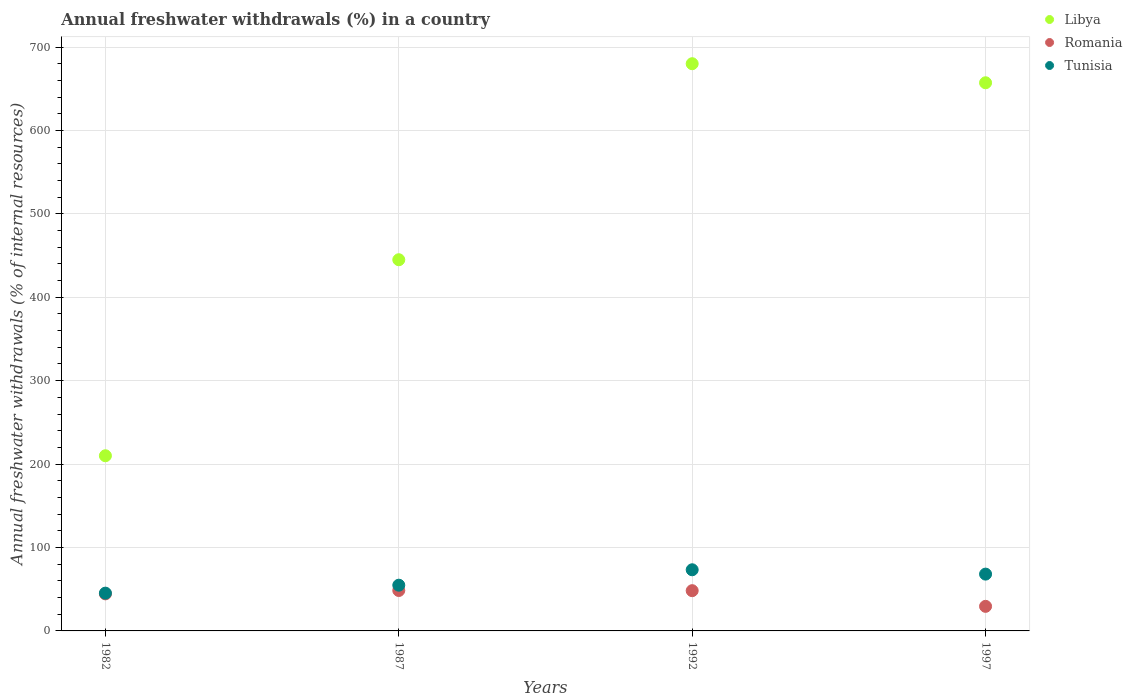Is the number of dotlines equal to the number of legend labels?
Ensure brevity in your answer.  Yes. What is the percentage of annual freshwater withdrawals in Romania in 1982?
Keep it short and to the point. 44.44. Across all years, what is the maximum percentage of annual freshwater withdrawals in Libya?
Make the answer very short. 680. Across all years, what is the minimum percentage of annual freshwater withdrawals in Tunisia?
Offer a very short reply. 45.29. What is the total percentage of annual freshwater withdrawals in Romania in the graph?
Your answer should be very brief. 170.61. What is the difference between the percentage of annual freshwater withdrawals in Tunisia in 1982 and that in 1987?
Ensure brevity in your answer.  -9.54. What is the difference between the percentage of annual freshwater withdrawals in Romania in 1992 and the percentage of annual freshwater withdrawals in Tunisia in 1982?
Make the answer very short. 2.96. What is the average percentage of annual freshwater withdrawals in Libya per year?
Make the answer very short. 498.04. In the year 1997, what is the difference between the percentage of annual freshwater withdrawals in Romania and percentage of annual freshwater withdrawals in Tunisia?
Make the answer very short. -38.65. What is the ratio of the percentage of annual freshwater withdrawals in Libya in 1992 to that in 1997?
Provide a succinct answer. 1.03. Is the percentage of annual freshwater withdrawals in Tunisia in 1987 less than that in 1997?
Your response must be concise. Yes. What is the difference between the highest and the second highest percentage of annual freshwater withdrawals in Romania?
Your answer should be very brief. 0.21. What is the difference between the highest and the lowest percentage of annual freshwater withdrawals in Tunisia?
Your answer should be very brief. 28.01. Is the sum of the percentage of annual freshwater withdrawals in Romania in 1987 and 1992 greater than the maximum percentage of annual freshwater withdrawals in Libya across all years?
Your answer should be compact. No. Is it the case that in every year, the sum of the percentage of annual freshwater withdrawals in Libya and percentage of annual freshwater withdrawals in Tunisia  is greater than the percentage of annual freshwater withdrawals in Romania?
Keep it short and to the point. Yes. Does the percentage of annual freshwater withdrawals in Libya monotonically increase over the years?
Provide a succinct answer. No. Is the percentage of annual freshwater withdrawals in Romania strictly greater than the percentage of annual freshwater withdrawals in Tunisia over the years?
Your response must be concise. No. Is the percentage of annual freshwater withdrawals in Libya strictly less than the percentage of annual freshwater withdrawals in Tunisia over the years?
Ensure brevity in your answer.  No. How many dotlines are there?
Your answer should be compact. 3. Are the values on the major ticks of Y-axis written in scientific E-notation?
Offer a very short reply. No. How many legend labels are there?
Your response must be concise. 3. What is the title of the graph?
Make the answer very short. Annual freshwater withdrawals (%) in a country. Does "China" appear as one of the legend labels in the graph?
Your answer should be compact. No. What is the label or title of the X-axis?
Offer a very short reply. Years. What is the label or title of the Y-axis?
Offer a very short reply. Annual freshwater withdrawals (% of internal resources). What is the Annual freshwater withdrawals (% of internal resources) in Libya in 1982?
Your response must be concise. 210. What is the Annual freshwater withdrawals (% of internal resources) in Romania in 1982?
Provide a succinct answer. 44.44. What is the Annual freshwater withdrawals (% of internal resources) in Tunisia in 1982?
Your answer should be compact. 45.29. What is the Annual freshwater withdrawals (% of internal resources) in Libya in 1987?
Provide a short and direct response. 445. What is the Annual freshwater withdrawals (% of internal resources) in Romania in 1987?
Your answer should be very brief. 48.46. What is the Annual freshwater withdrawals (% of internal resources) of Tunisia in 1987?
Provide a short and direct response. 54.83. What is the Annual freshwater withdrawals (% of internal resources) in Libya in 1992?
Give a very brief answer. 680. What is the Annual freshwater withdrawals (% of internal resources) of Romania in 1992?
Make the answer very short. 48.25. What is the Annual freshwater withdrawals (% of internal resources) in Tunisia in 1992?
Your answer should be compact. 73.3. What is the Annual freshwater withdrawals (% of internal resources) in Libya in 1997?
Provide a short and direct response. 657.14. What is the Annual freshwater withdrawals (% of internal resources) in Romania in 1997?
Your answer should be very brief. 29.46. What is the Annual freshwater withdrawals (% of internal resources) in Tunisia in 1997?
Your answer should be very brief. 68.1. Across all years, what is the maximum Annual freshwater withdrawals (% of internal resources) in Libya?
Offer a very short reply. 680. Across all years, what is the maximum Annual freshwater withdrawals (% of internal resources) of Romania?
Offer a terse response. 48.46. Across all years, what is the maximum Annual freshwater withdrawals (% of internal resources) of Tunisia?
Provide a succinct answer. 73.3. Across all years, what is the minimum Annual freshwater withdrawals (% of internal resources) of Libya?
Provide a short and direct response. 210. Across all years, what is the minimum Annual freshwater withdrawals (% of internal resources) in Romania?
Keep it short and to the point. 29.46. Across all years, what is the minimum Annual freshwater withdrawals (% of internal resources) in Tunisia?
Give a very brief answer. 45.29. What is the total Annual freshwater withdrawals (% of internal resources) in Libya in the graph?
Offer a terse response. 1992.14. What is the total Annual freshwater withdrawals (% of internal resources) in Romania in the graph?
Offer a terse response. 170.61. What is the total Annual freshwater withdrawals (% of internal resources) of Tunisia in the graph?
Offer a very short reply. 241.53. What is the difference between the Annual freshwater withdrawals (% of internal resources) of Libya in 1982 and that in 1987?
Keep it short and to the point. -235. What is the difference between the Annual freshwater withdrawals (% of internal resources) of Romania in 1982 and that in 1987?
Provide a short and direct response. -4.02. What is the difference between the Annual freshwater withdrawals (% of internal resources) in Tunisia in 1982 and that in 1987?
Your answer should be compact. -9.54. What is the difference between the Annual freshwater withdrawals (% of internal resources) in Libya in 1982 and that in 1992?
Keep it short and to the point. -470. What is the difference between the Annual freshwater withdrawals (% of internal resources) in Romania in 1982 and that in 1992?
Your response must be concise. -3.81. What is the difference between the Annual freshwater withdrawals (% of internal resources) of Tunisia in 1982 and that in 1992?
Give a very brief answer. -28.01. What is the difference between the Annual freshwater withdrawals (% of internal resources) in Libya in 1982 and that in 1997?
Make the answer very short. -447.14. What is the difference between the Annual freshwater withdrawals (% of internal resources) of Romania in 1982 and that in 1997?
Keep it short and to the point. 14.99. What is the difference between the Annual freshwater withdrawals (% of internal resources) of Tunisia in 1982 and that in 1997?
Make the answer very short. -22.81. What is the difference between the Annual freshwater withdrawals (% of internal resources) of Libya in 1987 and that in 1992?
Your answer should be compact. -235. What is the difference between the Annual freshwater withdrawals (% of internal resources) of Romania in 1987 and that in 1992?
Keep it short and to the point. 0.21. What is the difference between the Annual freshwater withdrawals (% of internal resources) of Tunisia in 1987 and that in 1992?
Your answer should be compact. -18.47. What is the difference between the Annual freshwater withdrawals (% of internal resources) of Libya in 1987 and that in 1997?
Make the answer very short. -212.14. What is the difference between the Annual freshwater withdrawals (% of internal resources) in Romania in 1987 and that in 1997?
Your answer should be very brief. 19.01. What is the difference between the Annual freshwater withdrawals (% of internal resources) in Tunisia in 1987 and that in 1997?
Your answer should be very brief. -13.28. What is the difference between the Annual freshwater withdrawals (% of internal resources) of Libya in 1992 and that in 1997?
Your response must be concise. 22.86. What is the difference between the Annual freshwater withdrawals (% of internal resources) of Romania in 1992 and that in 1997?
Offer a terse response. 18.79. What is the difference between the Annual freshwater withdrawals (% of internal resources) in Tunisia in 1992 and that in 1997?
Offer a terse response. 5.2. What is the difference between the Annual freshwater withdrawals (% of internal resources) of Libya in 1982 and the Annual freshwater withdrawals (% of internal resources) of Romania in 1987?
Offer a terse response. 161.54. What is the difference between the Annual freshwater withdrawals (% of internal resources) of Libya in 1982 and the Annual freshwater withdrawals (% of internal resources) of Tunisia in 1987?
Your response must be concise. 155.17. What is the difference between the Annual freshwater withdrawals (% of internal resources) in Romania in 1982 and the Annual freshwater withdrawals (% of internal resources) in Tunisia in 1987?
Provide a succinct answer. -10.38. What is the difference between the Annual freshwater withdrawals (% of internal resources) in Libya in 1982 and the Annual freshwater withdrawals (% of internal resources) in Romania in 1992?
Provide a short and direct response. 161.75. What is the difference between the Annual freshwater withdrawals (% of internal resources) in Libya in 1982 and the Annual freshwater withdrawals (% of internal resources) in Tunisia in 1992?
Keep it short and to the point. 136.7. What is the difference between the Annual freshwater withdrawals (% of internal resources) of Romania in 1982 and the Annual freshwater withdrawals (% of internal resources) of Tunisia in 1992?
Ensure brevity in your answer.  -28.86. What is the difference between the Annual freshwater withdrawals (% of internal resources) in Libya in 1982 and the Annual freshwater withdrawals (% of internal resources) in Romania in 1997?
Offer a very short reply. 180.54. What is the difference between the Annual freshwater withdrawals (% of internal resources) of Libya in 1982 and the Annual freshwater withdrawals (% of internal resources) of Tunisia in 1997?
Provide a short and direct response. 141.9. What is the difference between the Annual freshwater withdrawals (% of internal resources) in Romania in 1982 and the Annual freshwater withdrawals (% of internal resources) in Tunisia in 1997?
Keep it short and to the point. -23.66. What is the difference between the Annual freshwater withdrawals (% of internal resources) of Libya in 1987 and the Annual freshwater withdrawals (% of internal resources) of Romania in 1992?
Provide a succinct answer. 396.75. What is the difference between the Annual freshwater withdrawals (% of internal resources) of Libya in 1987 and the Annual freshwater withdrawals (% of internal resources) of Tunisia in 1992?
Make the answer very short. 371.7. What is the difference between the Annual freshwater withdrawals (% of internal resources) of Romania in 1987 and the Annual freshwater withdrawals (% of internal resources) of Tunisia in 1992?
Your response must be concise. -24.84. What is the difference between the Annual freshwater withdrawals (% of internal resources) in Libya in 1987 and the Annual freshwater withdrawals (% of internal resources) in Romania in 1997?
Make the answer very short. 415.54. What is the difference between the Annual freshwater withdrawals (% of internal resources) of Libya in 1987 and the Annual freshwater withdrawals (% of internal resources) of Tunisia in 1997?
Your response must be concise. 376.9. What is the difference between the Annual freshwater withdrawals (% of internal resources) in Romania in 1987 and the Annual freshwater withdrawals (% of internal resources) in Tunisia in 1997?
Make the answer very short. -19.64. What is the difference between the Annual freshwater withdrawals (% of internal resources) of Libya in 1992 and the Annual freshwater withdrawals (% of internal resources) of Romania in 1997?
Provide a short and direct response. 650.54. What is the difference between the Annual freshwater withdrawals (% of internal resources) of Libya in 1992 and the Annual freshwater withdrawals (% of internal resources) of Tunisia in 1997?
Make the answer very short. 611.9. What is the difference between the Annual freshwater withdrawals (% of internal resources) of Romania in 1992 and the Annual freshwater withdrawals (% of internal resources) of Tunisia in 1997?
Offer a very short reply. -19.85. What is the average Annual freshwater withdrawals (% of internal resources) of Libya per year?
Provide a succinct answer. 498.04. What is the average Annual freshwater withdrawals (% of internal resources) in Romania per year?
Make the answer very short. 42.65. What is the average Annual freshwater withdrawals (% of internal resources) of Tunisia per year?
Your response must be concise. 60.38. In the year 1982, what is the difference between the Annual freshwater withdrawals (% of internal resources) of Libya and Annual freshwater withdrawals (% of internal resources) of Romania?
Your response must be concise. 165.56. In the year 1982, what is the difference between the Annual freshwater withdrawals (% of internal resources) in Libya and Annual freshwater withdrawals (% of internal resources) in Tunisia?
Offer a terse response. 164.71. In the year 1982, what is the difference between the Annual freshwater withdrawals (% of internal resources) in Romania and Annual freshwater withdrawals (% of internal resources) in Tunisia?
Offer a terse response. -0.85. In the year 1987, what is the difference between the Annual freshwater withdrawals (% of internal resources) in Libya and Annual freshwater withdrawals (% of internal resources) in Romania?
Provide a short and direct response. 396.54. In the year 1987, what is the difference between the Annual freshwater withdrawals (% of internal resources) of Libya and Annual freshwater withdrawals (% of internal resources) of Tunisia?
Offer a terse response. 390.17. In the year 1987, what is the difference between the Annual freshwater withdrawals (% of internal resources) in Romania and Annual freshwater withdrawals (% of internal resources) in Tunisia?
Offer a very short reply. -6.36. In the year 1992, what is the difference between the Annual freshwater withdrawals (% of internal resources) in Libya and Annual freshwater withdrawals (% of internal resources) in Romania?
Offer a very short reply. 631.75. In the year 1992, what is the difference between the Annual freshwater withdrawals (% of internal resources) in Libya and Annual freshwater withdrawals (% of internal resources) in Tunisia?
Your response must be concise. 606.7. In the year 1992, what is the difference between the Annual freshwater withdrawals (% of internal resources) in Romania and Annual freshwater withdrawals (% of internal resources) in Tunisia?
Provide a short and direct response. -25.05. In the year 1997, what is the difference between the Annual freshwater withdrawals (% of internal resources) of Libya and Annual freshwater withdrawals (% of internal resources) of Romania?
Provide a succinct answer. 627.69. In the year 1997, what is the difference between the Annual freshwater withdrawals (% of internal resources) in Libya and Annual freshwater withdrawals (% of internal resources) in Tunisia?
Provide a succinct answer. 589.04. In the year 1997, what is the difference between the Annual freshwater withdrawals (% of internal resources) of Romania and Annual freshwater withdrawals (% of internal resources) of Tunisia?
Your response must be concise. -38.65. What is the ratio of the Annual freshwater withdrawals (% of internal resources) in Libya in 1982 to that in 1987?
Offer a very short reply. 0.47. What is the ratio of the Annual freshwater withdrawals (% of internal resources) in Romania in 1982 to that in 1987?
Offer a terse response. 0.92. What is the ratio of the Annual freshwater withdrawals (% of internal resources) of Tunisia in 1982 to that in 1987?
Provide a short and direct response. 0.83. What is the ratio of the Annual freshwater withdrawals (% of internal resources) in Libya in 1982 to that in 1992?
Offer a very short reply. 0.31. What is the ratio of the Annual freshwater withdrawals (% of internal resources) in Romania in 1982 to that in 1992?
Make the answer very short. 0.92. What is the ratio of the Annual freshwater withdrawals (% of internal resources) in Tunisia in 1982 to that in 1992?
Your answer should be compact. 0.62. What is the ratio of the Annual freshwater withdrawals (% of internal resources) of Libya in 1982 to that in 1997?
Ensure brevity in your answer.  0.32. What is the ratio of the Annual freshwater withdrawals (% of internal resources) in Romania in 1982 to that in 1997?
Provide a succinct answer. 1.51. What is the ratio of the Annual freshwater withdrawals (% of internal resources) in Tunisia in 1982 to that in 1997?
Your answer should be very brief. 0.67. What is the ratio of the Annual freshwater withdrawals (% of internal resources) of Libya in 1987 to that in 1992?
Keep it short and to the point. 0.65. What is the ratio of the Annual freshwater withdrawals (% of internal resources) in Tunisia in 1987 to that in 1992?
Your answer should be very brief. 0.75. What is the ratio of the Annual freshwater withdrawals (% of internal resources) of Libya in 1987 to that in 1997?
Offer a very short reply. 0.68. What is the ratio of the Annual freshwater withdrawals (% of internal resources) of Romania in 1987 to that in 1997?
Your answer should be compact. 1.65. What is the ratio of the Annual freshwater withdrawals (% of internal resources) in Tunisia in 1987 to that in 1997?
Keep it short and to the point. 0.81. What is the ratio of the Annual freshwater withdrawals (% of internal resources) of Libya in 1992 to that in 1997?
Offer a very short reply. 1.03. What is the ratio of the Annual freshwater withdrawals (% of internal resources) of Romania in 1992 to that in 1997?
Offer a very short reply. 1.64. What is the ratio of the Annual freshwater withdrawals (% of internal resources) of Tunisia in 1992 to that in 1997?
Keep it short and to the point. 1.08. What is the difference between the highest and the second highest Annual freshwater withdrawals (% of internal resources) of Libya?
Provide a succinct answer. 22.86. What is the difference between the highest and the second highest Annual freshwater withdrawals (% of internal resources) in Romania?
Provide a succinct answer. 0.21. What is the difference between the highest and the second highest Annual freshwater withdrawals (% of internal resources) in Tunisia?
Keep it short and to the point. 5.2. What is the difference between the highest and the lowest Annual freshwater withdrawals (% of internal resources) of Libya?
Your answer should be very brief. 470. What is the difference between the highest and the lowest Annual freshwater withdrawals (% of internal resources) in Romania?
Provide a short and direct response. 19.01. What is the difference between the highest and the lowest Annual freshwater withdrawals (% of internal resources) in Tunisia?
Your answer should be compact. 28.01. 